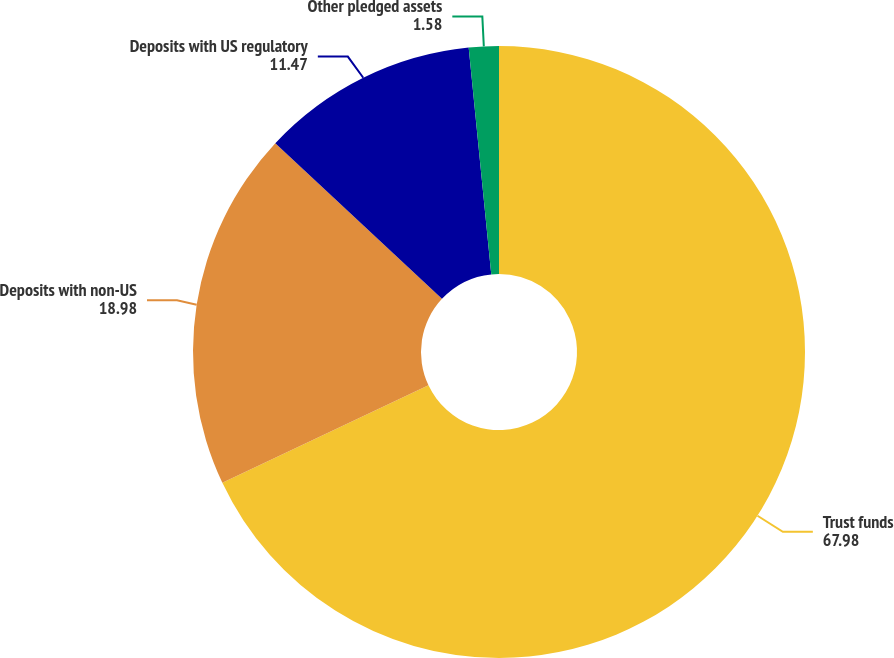<chart> <loc_0><loc_0><loc_500><loc_500><pie_chart><fcel>Trust funds<fcel>Deposits with non-US<fcel>Deposits with US regulatory<fcel>Other pledged assets<nl><fcel>67.98%<fcel>18.98%<fcel>11.47%<fcel>1.58%<nl></chart> 